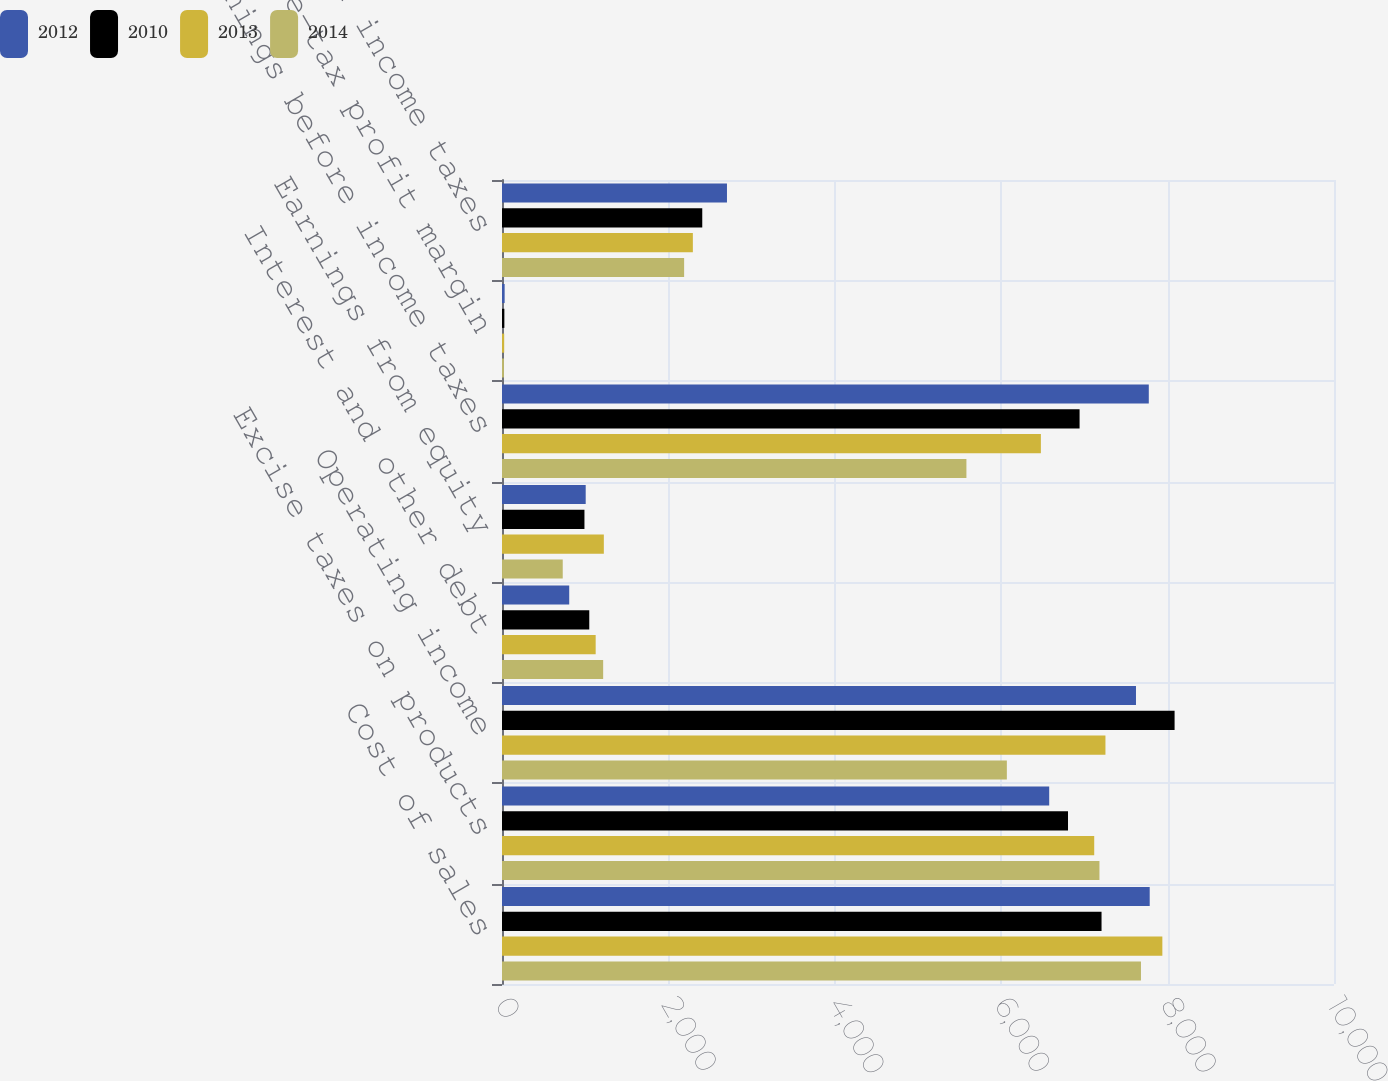<chart> <loc_0><loc_0><loc_500><loc_500><stacked_bar_chart><ecel><fcel>Cost of sales<fcel>Excise taxes on products<fcel>Operating income<fcel>Interest and other debt<fcel>Earnings from equity<fcel>Earnings before income taxes<fcel>Pre-tax profit margin<fcel>Provision for income taxes<nl><fcel>2012<fcel>7785<fcel>6577<fcel>7620<fcel>808<fcel>1006<fcel>7774<fcel>31.7<fcel>2704<nl><fcel>2010<fcel>7206<fcel>6803<fcel>8084<fcel>1049<fcel>991<fcel>6942<fcel>28.4<fcel>2407<nl><fcel>2013<fcel>7937<fcel>7118<fcel>7253<fcel>1126<fcel>1224<fcel>6477<fcel>26.3<fcel>2294<nl><fcel>2014<fcel>7680<fcel>7181<fcel>6068<fcel>1216<fcel>730<fcel>5582<fcel>23.5<fcel>2189<nl></chart> 